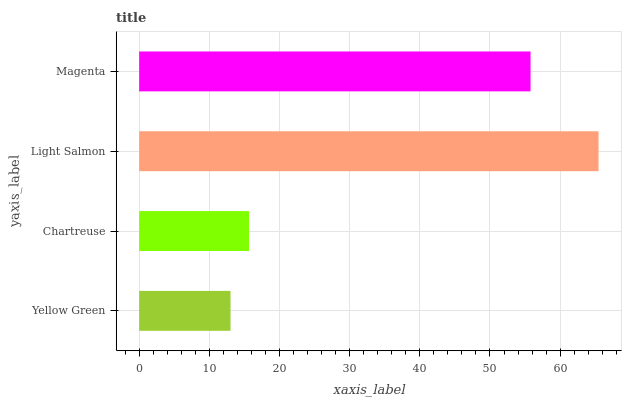Is Yellow Green the minimum?
Answer yes or no. Yes. Is Light Salmon the maximum?
Answer yes or no. Yes. Is Chartreuse the minimum?
Answer yes or no. No. Is Chartreuse the maximum?
Answer yes or no. No. Is Chartreuse greater than Yellow Green?
Answer yes or no. Yes. Is Yellow Green less than Chartreuse?
Answer yes or no. Yes. Is Yellow Green greater than Chartreuse?
Answer yes or no. No. Is Chartreuse less than Yellow Green?
Answer yes or no. No. Is Magenta the high median?
Answer yes or no. Yes. Is Chartreuse the low median?
Answer yes or no. Yes. Is Chartreuse the high median?
Answer yes or no. No. Is Light Salmon the low median?
Answer yes or no. No. 